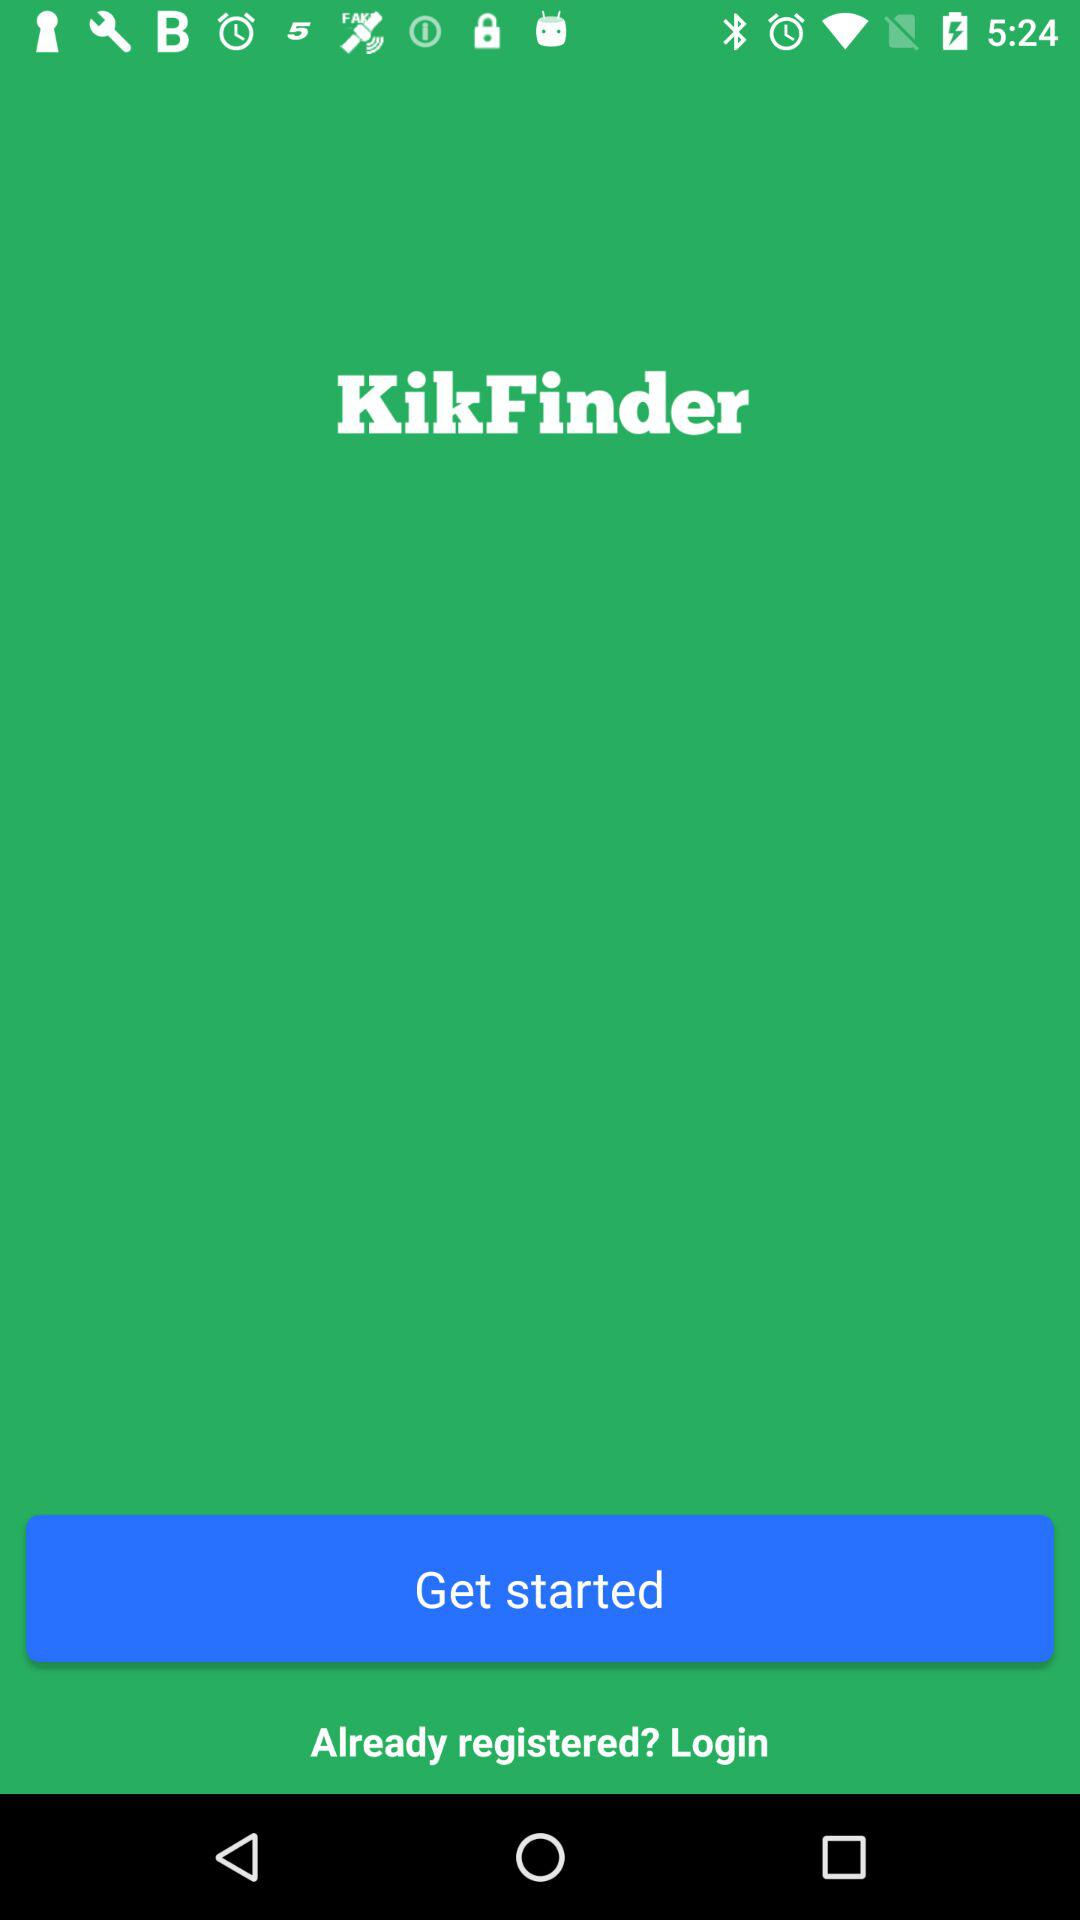What is the app name? The app name is "KikFinder". 